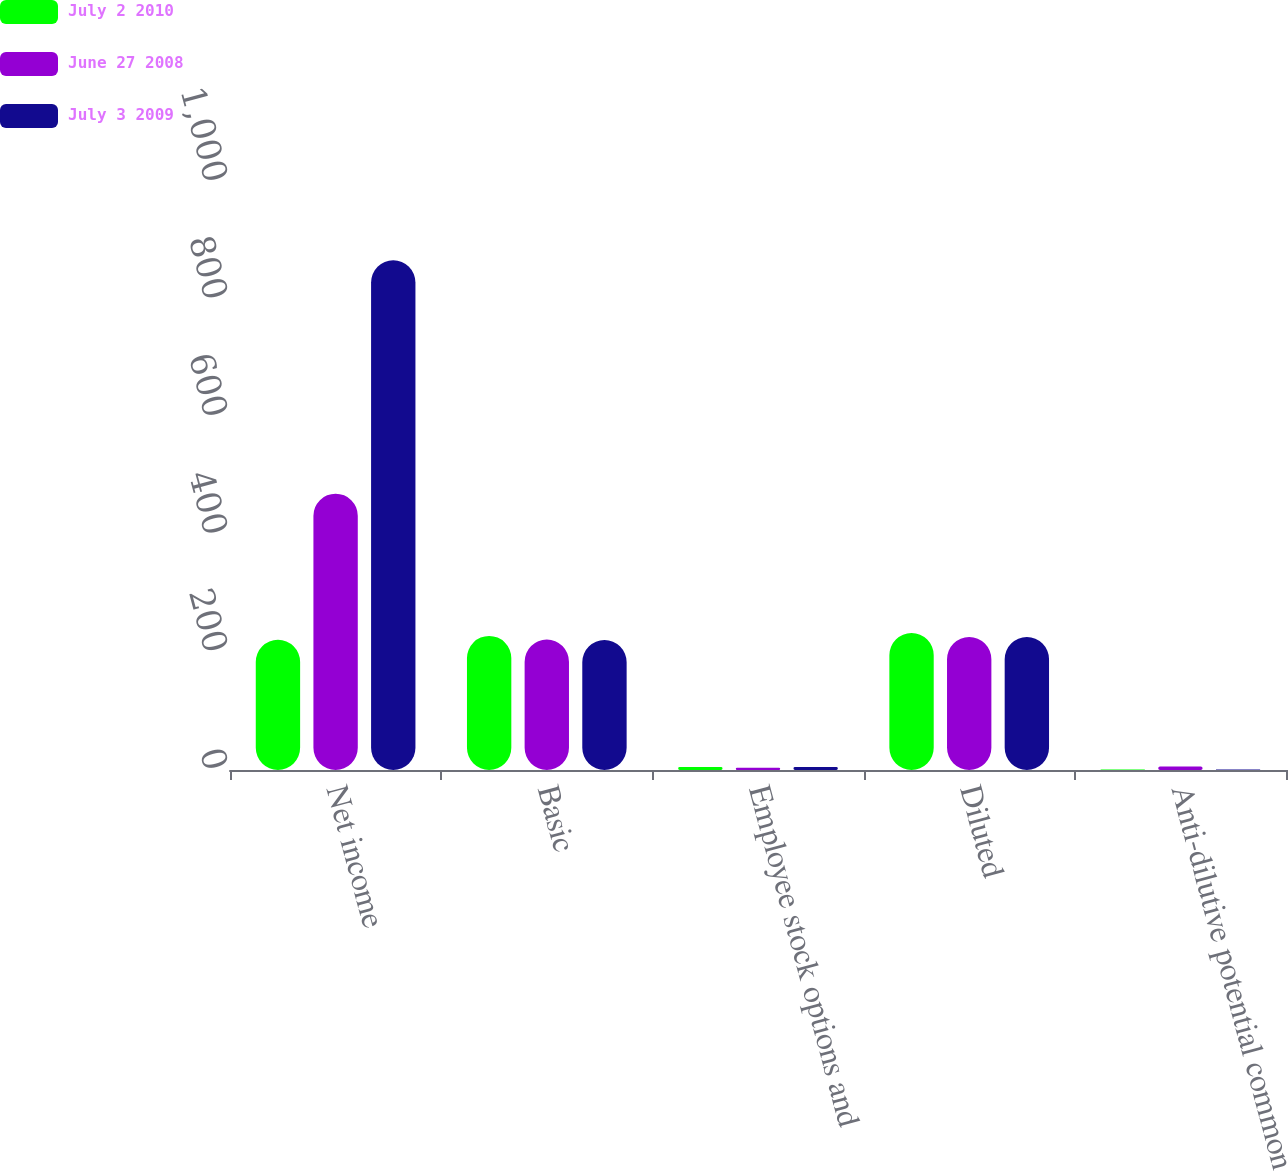Convert chart to OTSL. <chart><loc_0><loc_0><loc_500><loc_500><stacked_bar_chart><ecel><fcel>Net income<fcel>Basic<fcel>Employee stock options and<fcel>Diluted<fcel>Anti-dilutive potential common<nl><fcel>July 2 2010<fcel>221.5<fcel>228<fcel>5<fcel>233<fcel>1<nl><fcel>June 27 2008<fcel>470<fcel>222<fcel>4<fcel>226<fcel>6<nl><fcel>July 3 2009<fcel>867<fcel>221<fcel>5<fcel>226<fcel>1<nl></chart> 